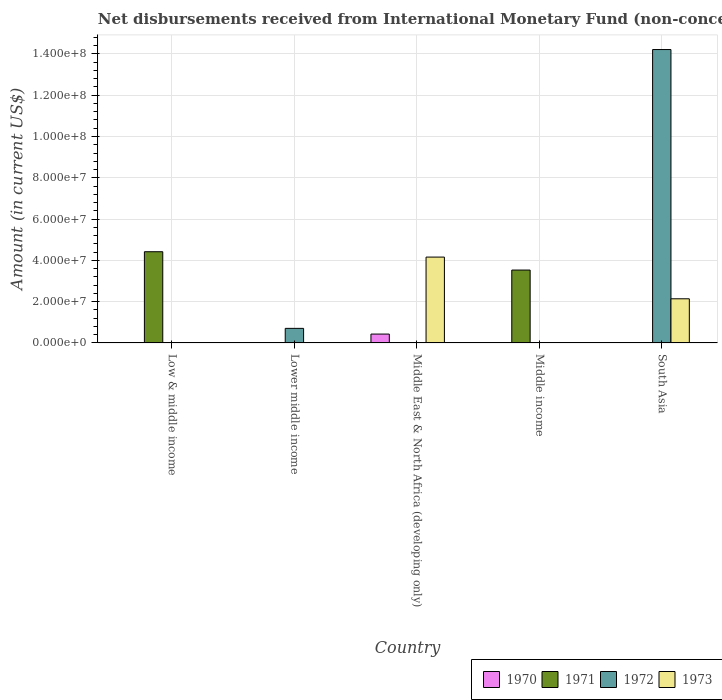How many different coloured bars are there?
Provide a succinct answer. 4. Are the number of bars per tick equal to the number of legend labels?
Offer a very short reply. No. How many bars are there on the 4th tick from the right?
Your response must be concise. 1. What is the amount of disbursements received from International Monetary Fund in 1971 in Middle income?
Offer a very short reply. 3.53e+07. Across all countries, what is the maximum amount of disbursements received from International Monetary Fund in 1973?
Offer a very short reply. 4.16e+07. Across all countries, what is the minimum amount of disbursements received from International Monetary Fund in 1971?
Offer a terse response. 0. What is the total amount of disbursements received from International Monetary Fund in 1970 in the graph?
Make the answer very short. 4.30e+06. What is the difference between the amount of disbursements received from International Monetary Fund in 1972 in Lower middle income and that in South Asia?
Make the answer very short. -1.35e+08. What is the difference between the amount of disbursements received from International Monetary Fund in 1972 in Lower middle income and the amount of disbursements received from International Monetary Fund in 1973 in Low & middle income?
Your answer should be compact. 7.06e+06. What is the average amount of disbursements received from International Monetary Fund in 1971 per country?
Offer a terse response. 1.59e+07. What is the difference between the amount of disbursements received from International Monetary Fund of/in 1970 and amount of disbursements received from International Monetary Fund of/in 1973 in Middle East & North Africa (developing only)?
Keep it short and to the point. -3.73e+07. In how many countries, is the amount of disbursements received from International Monetary Fund in 1972 greater than 4000000 US$?
Give a very brief answer. 2. What is the ratio of the amount of disbursements received from International Monetary Fund in 1972 in Lower middle income to that in South Asia?
Provide a succinct answer. 0.05. What is the difference between the highest and the lowest amount of disbursements received from International Monetary Fund in 1970?
Your response must be concise. 4.30e+06. Are all the bars in the graph horizontal?
Provide a short and direct response. No. How many countries are there in the graph?
Your response must be concise. 5. What is the difference between two consecutive major ticks on the Y-axis?
Your answer should be compact. 2.00e+07. Are the values on the major ticks of Y-axis written in scientific E-notation?
Your response must be concise. Yes. How many legend labels are there?
Your answer should be compact. 4. How are the legend labels stacked?
Your answer should be very brief. Horizontal. What is the title of the graph?
Keep it short and to the point. Net disbursements received from International Monetary Fund (non-concessional). Does "1991" appear as one of the legend labels in the graph?
Make the answer very short. No. What is the label or title of the X-axis?
Your response must be concise. Country. What is the label or title of the Y-axis?
Your response must be concise. Amount (in current US$). What is the Amount (in current US$) of 1970 in Low & middle income?
Provide a short and direct response. 0. What is the Amount (in current US$) in 1971 in Low & middle income?
Your answer should be very brief. 4.42e+07. What is the Amount (in current US$) of 1972 in Lower middle income?
Make the answer very short. 7.06e+06. What is the Amount (in current US$) of 1973 in Lower middle income?
Provide a short and direct response. 0. What is the Amount (in current US$) of 1970 in Middle East & North Africa (developing only)?
Offer a very short reply. 4.30e+06. What is the Amount (in current US$) of 1973 in Middle East & North Africa (developing only)?
Your response must be concise. 4.16e+07. What is the Amount (in current US$) in 1970 in Middle income?
Give a very brief answer. 0. What is the Amount (in current US$) of 1971 in Middle income?
Offer a very short reply. 3.53e+07. What is the Amount (in current US$) in 1972 in Middle income?
Your response must be concise. 0. What is the Amount (in current US$) in 1973 in Middle income?
Provide a short and direct response. 0. What is the Amount (in current US$) in 1970 in South Asia?
Your response must be concise. 0. What is the Amount (in current US$) in 1971 in South Asia?
Your answer should be very brief. 0. What is the Amount (in current US$) in 1972 in South Asia?
Provide a succinct answer. 1.42e+08. What is the Amount (in current US$) in 1973 in South Asia?
Offer a very short reply. 2.14e+07. Across all countries, what is the maximum Amount (in current US$) of 1970?
Your response must be concise. 4.30e+06. Across all countries, what is the maximum Amount (in current US$) of 1971?
Your response must be concise. 4.42e+07. Across all countries, what is the maximum Amount (in current US$) in 1972?
Give a very brief answer. 1.42e+08. Across all countries, what is the maximum Amount (in current US$) of 1973?
Your answer should be very brief. 4.16e+07. Across all countries, what is the minimum Amount (in current US$) of 1970?
Your answer should be very brief. 0. Across all countries, what is the minimum Amount (in current US$) in 1972?
Provide a succinct answer. 0. What is the total Amount (in current US$) in 1970 in the graph?
Provide a short and direct response. 4.30e+06. What is the total Amount (in current US$) in 1971 in the graph?
Provide a succinct answer. 7.95e+07. What is the total Amount (in current US$) in 1972 in the graph?
Ensure brevity in your answer.  1.49e+08. What is the total Amount (in current US$) of 1973 in the graph?
Give a very brief answer. 6.30e+07. What is the difference between the Amount (in current US$) in 1971 in Low & middle income and that in Middle income?
Your answer should be very brief. 8.88e+06. What is the difference between the Amount (in current US$) in 1972 in Lower middle income and that in South Asia?
Give a very brief answer. -1.35e+08. What is the difference between the Amount (in current US$) of 1973 in Middle East & North Africa (developing only) and that in South Asia?
Your answer should be compact. 2.02e+07. What is the difference between the Amount (in current US$) in 1971 in Low & middle income and the Amount (in current US$) in 1972 in Lower middle income?
Your response must be concise. 3.71e+07. What is the difference between the Amount (in current US$) in 1971 in Low & middle income and the Amount (in current US$) in 1973 in Middle East & North Africa (developing only)?
Provide a short and direct response. 2.60e+06. What is the difference between the Amount (in current US$) in 1971 in Low & middle income and the Amount (in current US$) in 1972 in South Asia?
Make the answer very short. -9.79e+07. What is the difference between the Amount (in current US$) in 1971 in Low & middle income and the Amount (in current US$) in 1973 in South Asia?
Provide a short and direct response. 2.28e+07. What is the difference between the Amount (in current US$) of 1972 in Lower middle income and the Amount (in current US$) of 1973 in Middle East & North Africa (developing only)?
Your response must be concise. -3.45e+07. What is the difference between the Amount (in current US$) in 1972 in Lower middle income and the Amount (in current US$) in 1973 in South Asia?
Provide a succinct answer. -1.43e+07. What is the difference between the Amount (in current US$) of 1970 in Middle East & North Africa (developing only) and the Amount (in current US$) of 1971 in Middle income?
Give a very brief answer. -3.10e+07. What is the difference between the Amount (in current US$) of 1970 in Middle East & North Africa (developing only) and the Amount (in current US$) of 1972 in South Asia?
Make the answer very short. -1.38e+08. What is the difference between the Amount (in current US$) in 1970 in Middle East & North Africa (developing only) and the Amount (in current US$) in 1973 in South Asia?
Your answer should be very brief. -1.71e+07. What is the difference between the Amount (in current US$) in 1971 in Middle income and the Amount (in current US$) in 1972 in South Asia?
Provide a succinct answer. -1.07e+08. What is the difference between the Amount (in current US$) in 1971 in Middle income and the Amount (in current US$) in 1973 in South Asia?
Your answer should be compact. 1.39e+07. What is the average Amount (in current US$) in 1970 per country?
Your answer should be compact. 8.60e+05. What is the average Amount (in current US$) in 1971 per country?
Provide a succinct answer. 1.59e+07. What is the average Amount (in current US$) in 1972 per country?
Offer a terse response. 2.98e+07. What is the average Amount (in current US$) in 1973 per country?
Your answer should be compact. 1.26e+07. What is the difference between the Amount (in current US$) of 1970 and Amount (in current US$) of 1973 in Middle East & North Africa (developing only)?
Provide a succinct answer. -3.73e+07. What is the difference between the Amount (in current US$) in 1972 and Amount (in current US$) in 1973 in South Asia?
Your answer should be very brief. 1.21e+08. What is the ratio of the Amount (in current US$) of 1971 in Low & middle income to that in Middle income?
Your answer should be very brief. 1.25. What is the ratio of the Amount (in current US$) in 1972 in Lower middle income to that in South Asia?
Make the answer very short. 0.05. What is the ratio of the Amount (in current US$) in 1973 in Middle East & North Africa (developing only) to that in South Asia?
Provide a succinct answer. 1.94. What is the difference between the highest and the lowest Amount (in current US$) of 1970?
Ensure brevity in your answer.  4.30e+06. What is the difference between the highest and the lowest Amount (in current US$) in 1971?
Provide a succinct answer. 4.42e+07. What is the difference between the highest and the lowest Amount (in current US$) of 1972?
Make the answer very short. 1.42e+08. What is the difference between the highest and the lowest Amount (in current US$) in 1973?
Give a very brief answer. 4.16e+07. 